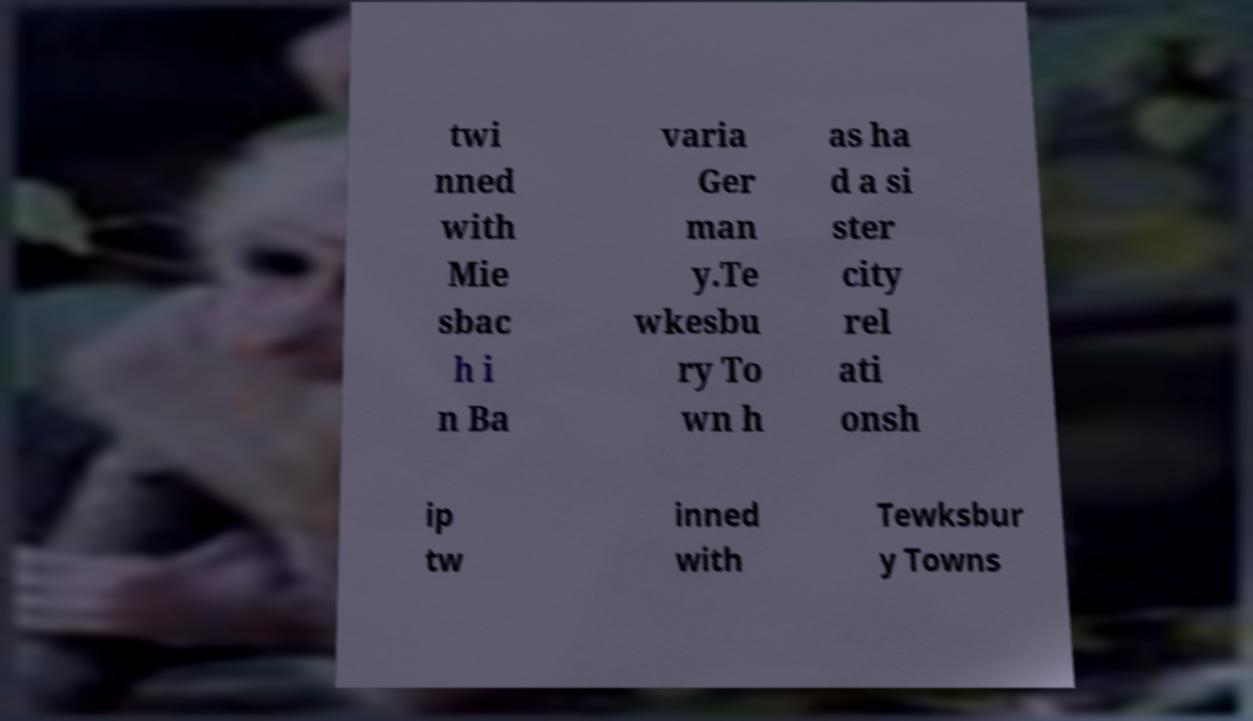Could you assist in decoding the text presented in this image and type it out clearly? twi nned with Mie sbac h i n Ba varia Ger man y.Te wkesbu ry To wn h as ha d a si ster city rel ati onsh ip tw inned with Tewksbur y Towns 